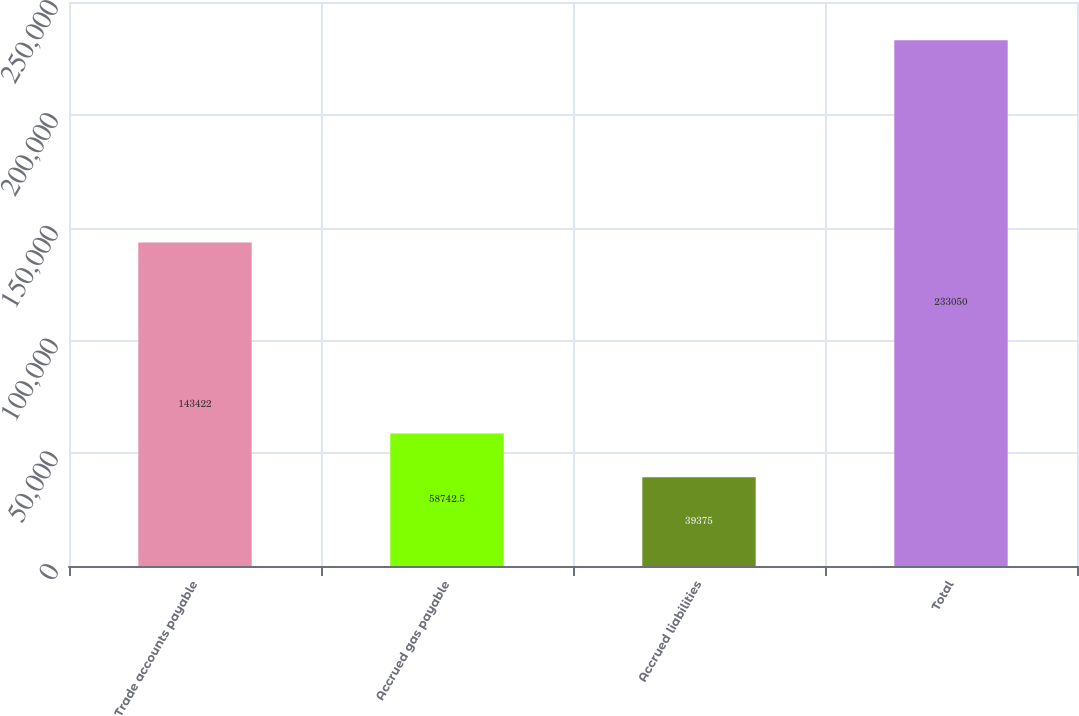Convert chart to OTSL. <chart><loc_0><loc_0><loc_500><loc_500><bar_chart><fcel>Trade accounts payable<fcel>Accrued gas payable<fcel>Accrued liabilities<fcel>Total<nl><fcel>143422<fcel>58742.5<fcel>39375<fcel>233050<nl></chart> 